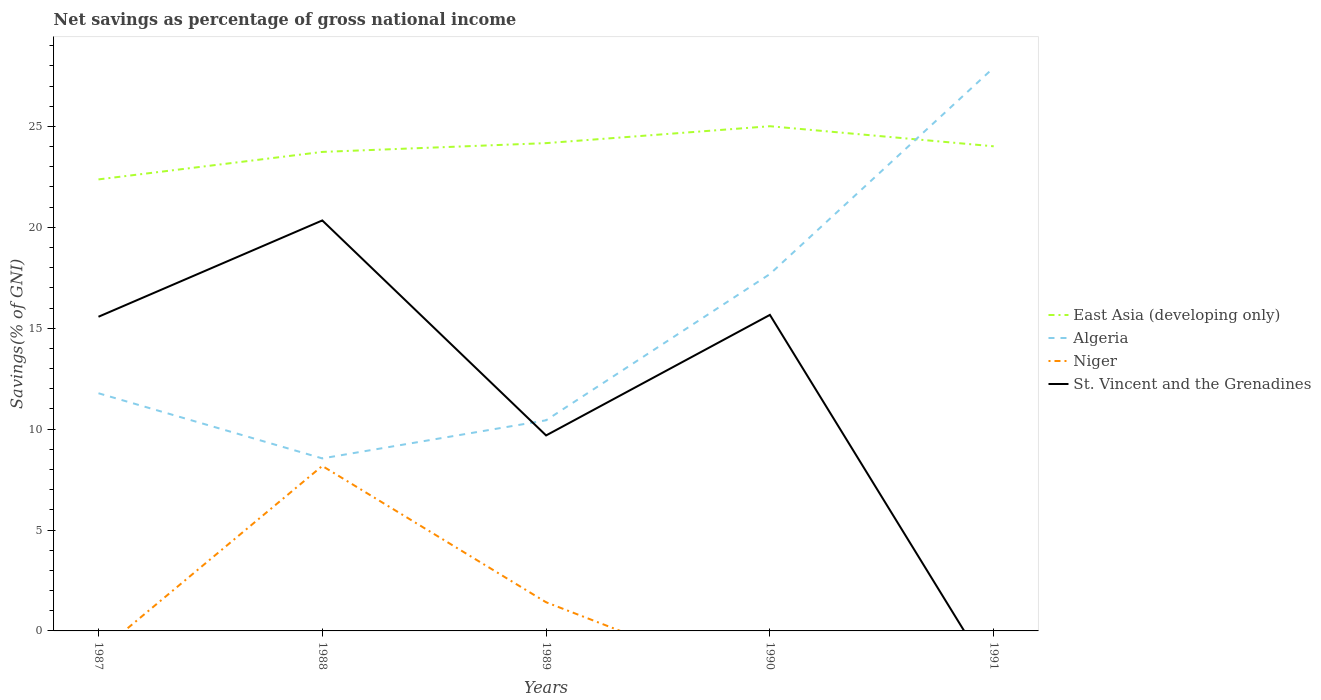How many different coloured lines are there?
Offer a very short reply. 4. Does the line corresponding to St. Vincent and the Grenadines intersect with the line corresponding to Niger?
Keep it short and to the point. Yes. What is the total total savings in Algeria in the graph?
Provide a short and direct response. -5.91. What is the difference between the highest and the second highest total savings in St. Vincent and the Grenadines?
Make the answer very short. 20.34. What is the difference between the highest and the lowest total savings in Algeria?
Offer a very short reply. 2. Is the total savings in Niger strictly greater than the total savings in East Asia (developing only) over the years?
Provide a succinct answer. Yes. Does the graph contain any zero values?
Your response must be concise. Yes. Does the graph contain grids?
Make the answer very short. No. Where does the legend appear in the graph?
Provide a short and direct response. Center right. How many legend labels are there?
Give a very brief answer. 4. How are the legend labels stacked?
Your answer should be very brief. Vertical. What is the title of the graph?
Ensure brevity in your answer.  Net savings as percentage of gross national income. Does "South Sudan" appear as one of the legend labels in the graph?
Provide a short and direct response. No. What is the label or title of the Y-axis?
Keep it short and to the point. Savings(% of GNI). What is the Savings(% of GNI) of East Asia (developing only) in 1987?
Provide a succinct answer. 22.38. What is the Savings(% of GNI) in Algeria in 1987?
Provide a succinct answer. 11.78. What is the Savings(% of GNI) of St. Vincent and the Grenadines in 1987?
Your response must be concise. 15.57. What is the Savings(% of GNI) of East Asia (developing only) in 1988?
Provide a succinct answer. 23.74. What is the Savings(% of GNI) of Algeria in 1988?
Your response must be concise. 8.55. What is the Savings(% of GNI) of Niger in 1988?
Keep it short and to the point. 8.18. What is the Savings(% of GNI) of St. Vincent and the Grenadines in 1988?
Provide a short and direct response. 20.34. What is the Savings(% of GNI) of East Asia (developing only) in 1989?
Provide a succinct answer. 24.17. What is the Savings(% of GNI) in Algeria in 1989?
Offer a very short reply. 10.44. What is the Savings(% of GNI) of Niger in 1989?
Provide a succinct answer. 1.42. What is the Savings(% of GNI) of St. Vincent and the Grenadines in 1989?
Your response must be concise. 9.69. What is the Savings(% of GNI) in East Asia (developing only) in 1990?
Provide a succinct answer. 25.01. What is the Savings(% of GNI) in Algeria in 1990?
Offer a terse response. 17.69. What is the Savings(% of GNI) in Niger in 1990?
Keep it short and to the point. 0. What is the Savings(% of GNI) in St. Vincent and the Grenadines in 1990?
Your answer should be compact. 15.66. What is the Savings(% of GNI) in East Asia (developing only) in 1991?
Offer a terse response. 24.02. What is the Savings(% of GNI) in Algeria in 1991?
Provide a succinct answer. 27.91. What is the Savings(% of GNI) in St. Vincent and the Grenadines in 1991?
Your answer should be very brief. 0. Across all years, what is the maximum Savings(% of GNI) in East Asia (developing only)?
Provide a short and direct response. 25.01. Across all years, what is the maximum Savings(% of GNI) of Algeria?
Your response must be concise. 27.91. Across all years, what is the maximum Savings(% of GNI) in Niger?
Offer a terse response. 8.18. Across all years, what is the maximum Savings(% of GNI) of St. Vincent and the Grenadines?
Offer a terse response. 20.34. Across all years, what is the minimum Savings(% of GNI) of East Asia (developing only)?
Offer a terse response. 22.38. Across all years, what is the minimum Savings(% of GNI) of Algeria?
Your response must be concise. 8.55. Across all years, what is the minimum Savings(% of GNI) in Niger?
Keep it short and to the point. 0. What is the total Savings(% of GNI) of East Asia (developing only) in the graph?
Your answer should be compact. 119.31. What is the total Savings(% of GNI) of Algeria in the graph?
Provide a short and direct response. 76.37. What is the total Savings(% of GNI) of Niger in the graph?
Make the answer very short. 9.6. What is the total Savings(% of GNI) of St. Vincent and the Grenadines in the graph?
Provide a short and direct response. 61.26. What is the difference between the Savings(% of GNI) of East Asia (developing only) in 1987 and that in 1988?
Offer a terse response. -1.36. What is the difference between the Savings(% of GNI) in Algeria in 1987 and that in 1988?
Keep it short and to the point. 3.23. What is the difference between the Savings(% of GNI) in St. Vincent and the Grenadines in 1987 and that in 1988?
Ensure brevity in your answer.  -4.77. What is the difference between the Savings(% of GNI) in East Asia (developing only) in 1987 and that in 1989?
Provide a succinct answer. -1.8. What is the difference between the Savings(% of GNI) in Algeria in 1987 and that in 1989?
Make the answer very short. 1.34. What is the difference between the Savings(% of GNI) of St. Vincent and the Grenadines in 1987 and that in 1989?
Offer a terse response. 5.88. What is the difference between the Savings(% of GNI) of East Asia (developing only) in 1987 and that in 1990?
Your answer should be compact. -2.63. What is the difference between the Savings(% of GNI) of Algeria in 1987 and that in 1990?
Your response must be concise. -5.91. What is the difference between the Savings(% of GNI) in St. Vincent and the Grenadines in 1987 and that in 1990?
Your answer should be very brief. -0.09. What is the difference between the Savings(% of GNI) in East Asia (developing only) in 1987 and that in 1991?
Your answer should be very brief. -1.64. What is the difference between the Savings(% of GNI) in Algeria in 1987 and that in 1991?
Your response must be concise. -16.14. What is the difference between the Savings(% of GNI) in East Asia (developing only) in 1988 and that in 1989?
Ensure brevity in your answer.  -0.44. What is the difference between the Savings(% of GNI) of Algeria in 1988 and that in 1989?
Give a very brief answer. -1.89. What is the difference between the Savings(% of GNI) of Niger in 1988 and that in 1989?
Keep it short and to the point. 6.76. What is the difference between the Savings(% of GNI) of St. Vincent and the Grenadines in 1988 and that in 1989?
Your answer should be very brief. 10.65. What is the difference between the Savings(% of GNI) of East Asia (developing only) in 1988 and that in 1990?
Keep it short and to the point. -1.27. What is the difference between the Savings(% of GNI) of Algeria in 1988 and that in 1990?
Your answer should be compact. -9.14. What is the difference between the Savings(% of GNI) in St. Vincent and the Grenadines in 1988 and that in 1990?
Provide a succinct answer. 4.68. What is the difference between the Savings(% of GNI) of East Asia (developing only) in 1988 and that in 1991?
Your response must be concise. -0.28. What is the difference between the Savings(% of GNI) in Algeria in 1988 and that in 1991?
Your answer should be very brief. -19.36. What is the difference between the Savings(% of GNI) in East Asia (developing only) in 1989 and that in 1990?
Your answer should be very brief. -0.84. What is the difference between the Savings(% of GNI) in Algeria in 1989 and that in 1990?
Your answer should be very brief. -7.25. What is the difference between the Savings(% of GNI) of St. Vincent and the Grenadines in 1989 and that in 1990?
Make the answer very short. -5.97. What is the difference between the Savings(% of GNI) of East Asia (developing only) in 1989 and that in 1991?
Make the answer very short. 0.16. What is the difference between the Savings(% of GNI) of Algeria in 1989 and that in 1991?
Give a very brief answer. -17.48. What is the difference between the Savings(% of GNI) in East Asia (developing only) in 1990 and that in 1991?
Provide a succinct answer. 1. What is the difference between the Savings(% of GNI) in Algeria in 1990 and that in 1991?
Provide a succinct answer. -10.23. What is the difference between the Savings(% of GNI) of East Asia (developing only) in 1987 and the Savings(% of GNI) of Algeria in 1988?
Offer a terse response. 13.83. What is the difference between the Savings(% of GNI) in East Asia (developing only) in 1987 and the Savings(% of GNI) in Niger in 1988?
Provide a short and direct response. 14.2. What is the difference between the Savings(% of GNI) in East Asia (developing only) in 1987 and the Savings(% of GNI) in St. Vincent and the Grenadines in 1988?
Offer a terse response. 2.03. What is the difference between the Savings(% of GNI) of Algeria in 1987 and the Savings(% of GNI) of Niger in 1988?
Make the answer very short. 3.6. What is the difference between the Savings(% of GNI) of Algeria in 1987 and the Savings(% of GNI) of St. Vincent and the Grenadines in 1988?
Provide a short and direct response. -8.56. What is the difference between the Savings(% of GNI) of East Asia (developing only) in 1987 and the Savings(% of GNI) of Algeria in 1989?
Keep it short and to the point. 11.94. What is the difference between the Savings(% of GNI) of East Asia (developing only) in 1987 and the Savings(% of GNI) of Niger in 1989?
Your answer should be very brief. 20.96. What is the difference between the Savings(% of GNI) in East Asia (developing only) in 1987 and the Savings(% of GNI) in St. Vincent and the Grenadines in 1989?
Keep it short and to the point. 12.69. What is the difference between the Savings(% of GNI) of Algeria in 1987 and the Savings(% of GNI) of Niger in 1989?
Offer a terse response. 10.36. What is the difference between the Savings(% of GNI) of Algeria in 1987 and the Savings(% of GNI) of St. Vincent and the Grenadines in 1989?
Your response must be concise. 2.09. What is the difference between the Savings(% of GNI) of East Asia (developing only) in 1987 and the Savings(% of GNI) of Algeria in 1990?
Your answer should be very brief. 4.69. What is the difference between the Savings(% of GNI) of East Asia (developing only) in 1987 and the Savings(% of GNI) of St. Vincent and the Grenadines in 1990?
Offer a very short reply. 6.71. What is the difference between the Savings(% of GNI) of Algeria in 1987 and the Savings(% of GNI) of St. Vincent and the Grenadines in 1990?
Ensure brevity in your answer.  -3.88. What is the difference between the Savings(% of GNI) of East Asia (developing only) in 1987 and the Savings(% of GNI) of Algeria in 1991?
Your answer should be very brief. -5.54. What is the difference between the Savings(% of GNI) in East Asia (developing only) in 1988 and the Savings(% of GNI) in Algeria in 1989?
Your answer should be compact. 13.3. What is the difference between the Savings(% of GNI) of East Asia (developing only) in 1988 and the Savings(% of GNI) of Niger in 1989?
Provide a succinct answer. 22.32. What is the difference between the Savings(% of GNI) of East Asia (developing only) in 1988 and the Savings(% of GNI) of St. Vincent and the Grenadines in 1989?
Provide a short and direct response. 14.05. What is the difference between the Savings(% of GNI) in Algeria in 1988 and the Savings(% of GNI) in Niger in 1989?
Your answer should be compact. 7.13. What is the difference between the Savings(% of GNI) of Algeria in 1988 and the Savings(% of GNI) of St. Vincent and the Grenadines in 1989?
Offer a terse response. -1.14. What is the difference between the Savings(% of GNI) of Niger in 1988 and the Savings(% of GNI) of St. Vincent and the Grenadines in 1989?
Provide a short and direct response. -1.51. What is the difference between the Savings(% of GNI) of East Asia (developing only) in 1988 and the Savings(% of GNI) of Algeria in 1990?
Offer a very short reply. 6.05. What is the difference between the Savings(% of GNI) in East Asia (developing only) in 1988 and the Savings(% of GNI) in St. Vincent and the Grenadines in 1990?
Your answer should be very brief. 8.08. What is the difference between the Savings(% of GNI) of Algeria in 1988 and the Savings(% of GNI) of St. Vincent and the Grenadines in 1990?
Your answer should be compact. -7.11. What is the difference between the Savings(% of GNI) of Niger in 1988 and the Savings(% of GNI) of St. Vincent and the Grenadines in 1990?
Ensure brevity in your answer.  -7.49. What is the difference between the Savings(% of GNI) of East Asia (developing only) in 1988 and the Savings(% of GNI) of Algeria in 1991?
Make the answer very short. -4.18. What is the difference between the Savings(% of GNI) of East Asia (developing only) in 1989 and the Savings(% of GNI) of Algeria in 1990?
Provide a short and direct response. 6.49. What is the difference between the Savings(% of GNI) in East Asia (developing only) in 1989 and the Savings(% of GNI) in St. Vincent and the Grenadines in 1990?
Offer a very short reply. 8.51. What is the difference between the Savings(% of GNI) of Algeria in 1989 and the Savings(% of GNI) of St. Vincent and the Grenadines in 1990?
Keep it short and to the point. -5.22. What is the difference between the Savings(% of GNI) of Niger in 1989 and the Savings(% of GNI) of St. Vincent and the Grenadines in 1990?
Offer a very short reply. -14.24. What is the difference between the Savings(% of GNI) of East Asia (developing only) in 1989 and the Savings(% of GNI) of Algeria in 1991?
Offer a terse response. -3.74. What is the difference between the Savings(% of GNI) of East Asia (developing only) in 1990 and the Savings(% of GNI) of Algeria in 1991?
Ensure brevity in your answer.  -2.9. What is the average Savings(% of GNI) of East Asia (developing only) per year?
Your response must be concise. 23.86. What is the average Savings(% of GNI) in Algeria per year?
Offer a terse response. 15.27. What is the average Savings(% of GNI) of Niger per year?
Your response must be concise. 1.92. What is the average Savings(% of GNI) of St. Vincent and the Grenadines per year?
Ensure brevity in your answer.  12.25. In the year 1987, what is the difference between the Savings(% of GNI) in East Asia (developing only) and Savings(% of GNI) in Algeria?
Your answer should be compact. 10.6. In the year 1987, what is the difference between the Savings(% of GNI) in East Asia (developing only) and Savings(% of GNI) in St. Vincent and the Grenadines?
Your response must be concise. 6.81. In the year 1987, what is the difference between the Savings(% of GNI) in Algeria and Savings(% of GNI) in St. Vincent and the Grenadines?
Offer a terse response. -3.79. In the year 1988, what is the difference between the Savings(% of GNI) of East Asia (developing only) and Savings(% of GNI) of Algeria?
Provide a succinct answer. 15.19. In the year 1988, what is the difference between the Savings(% of GNI) of East Asia (developing only) and Savings(% of GNI) of Niger?
Offer a terse response. 15.56. In the year 1988, what is the difference between the Savings(% of GNI) in East Asia (developing only) and Savings(% of GNI) in St. Vincent and the Grenadines?
Your answer should be compact. 3.4. In the year 1988, what is the difference between the Savings(% of GNI) of Algeria and Savings(% of GNI) of Niger?
Provide a succinct answer. 0.37. In the year 1988, what is the difference between the Savings(% of GNI) in Algeria and Savings(% of GNI) in St. Vincent and the Grenadines?
Your response must be concise. -11.79. In the year 1988, what is the difference between the Savings(% of GNI) in Niger and Savings(% of GNI) in St. Vincent and the Grenadines?
Keep it short and to the point. -12.17. In the year 1989, what is the difference between the Savings(% of GNI) of East Asia (developing only) and Savings(% of GNI) of Algeria?
Your answer should be very brief. 13.73. In the year 1989, what is the difference between the Savings(% of GNI) of East Asia (developing only) and Savings(% of GNI) of Niger?
Provide a succinct answer. 22.75. In the year 1989, what is the difference between the Savings(% of GNI) of East Asia (developing only) and Savings(% of GNI) of St. Vincent and the Grenadines?
Offer a very short reply. 14.49. In the year 1989, what is the difference between the Savings(% of GNI) in Algeria and Savings(% of GNI) in Niger?
Give a very brief answer. 9.02. In the year 1989, what is the difference between the Savings(% of GNI) in Algeria and Savings(% of GNI) in St. Vincent and the Grenadines?
Keep it short and to the point. 0.75. In the year 1989, what is the difference between the Savings(% of GNI) of Niger and Savings(% of GNI) of St. Vincent and the Grenadines?
Your answer should be very brief. -8.27. In the year 1990, what is the difference between the Savings(% of GNI) in East Asia (developing only) and Savings(% of GNI) in Algeria?
Your answer should be compact. 7.32. In the year 1990, what is the difference between the Savings(% of GNI) in East Asia (developing only) and Savings(% of GNI) in St. Vincent and the Grenadines?
Your answer should be very brief. 9.35. In the year 1990, what is the difference between the Savings(% of GNI) of Algeria and Savings(% of GNI) of St. Vincent and the Grenadines?
Offer a very short reply. 2.02. In the year 1991, what is the difference between the Savings(% of GNI) in East Asia (developing only) and Savings(% of GNI) in Algeria?
Ensure brevity in your answer.  -3.9. What is the ratio of the Savings(% of GNI) in East Asia (developing only) in 1987 to that in 1988?
Your answer should be very brief. 0.94. What is the ratio of the Savings(% of GNI) in Algeria in 1987 to that in 1988?
Give a very brief answer. 1.38. What is the ratio of the Savings(% of GNI) of St. Vincent and the Grenadines in 1987 to that in 1988?
Offer a very short reply. 0.77. What is the ratio of the Savings(% of GNI) in East Asia (developing only) in 1987 to that in 1989?
Your response must be concise. 0.93. What is the ratio of the Savings(% of GNI) in Algeria in 1987 to that in 1989?
Your response must be concise. 1.13. What is the ratio of the Savings(% of GNI) of St. Vincent and the Grenadines in 1987 to that in 1989?
Ensure brevity in your answer.  1.61. What is the ratio of the Savings(% of GNI) of East Asia (developing only) in 1987 to that in 1990?
Keep it short and to the point. 0.89. What is the ratio of the Savings(% of GNI) of Algeria in 1987 to that in 1990?
Provide a short and direct response. 0.67. What is the ratio of the Savings(% of GNI) of East Asia (developing only) in 1987 to that in 1991?
Offer a very short reply. 0.93. What is the ratio of the Savings(% of GNI) in Algeria in 1987 to that in 1991?
Make the answer very short. 0.42. What is the ratio of the Savings(% of GNI) of Algeria in 1988 to that in 1989?
Your answer should be compact. 0.82. What is the ratio of the Savings(% of GNI) in Niger in 1988 to that in 1989?
Keep it short and to the point. 5.76. What is the ratio of the Savings(% of GNI) of St. Vincent and the Grenadines in 1988 to that in 1989?
Provide a short and direct response. 2.1. What is the ratio of the Savings(% of GNI) in East Asia (developing only) in 1988 to that in 1990?
Offer a terse response. 0.95. What is the ratio of the Savings(% of GNI) of Algeria in 1988 to that in 1990?
Keep it short and to the point. 0.48. What is the ratio of the Savings(% of GNI) in St. Vincent and the Grenadines in 1988 to that in 1990?
Make the answer very short. 1.3. What is the ratio of the Savings(% of GNI) in East Asia (developing only) in 1988 to that in 1991?
Keep it short and to the point. 0.99. What is the ratio of the Savings(% of GNI) of Algeria in 1988 to that in 1991?
Provide a succinct answer. 0.31. What is the ratio of the Savings(% of GNI) of East Asia (developing only) in 1989 to that in 1990?
Make the answer very short. 0.97. What is the ratio of the Savings(% of GNI) of Algeria in 1989 to that in 1990?
Your response must be concise. 0.59. What is the ratio of the Savings(% of GNI) of St. Vincent and the Grenadines in 1989 to that in 1990?
Make the answer very short. 0.62. What is the ratio of the Savings(% of GNI) of East Asia (developing only) in 1989 to that in 1991?
Provide a short and direct response. 1.01. What is the ratio of the Savings(% of GNI) in Algeria in 1989 to that in 1991?
Provide a short and direct response. 0.37. What is the ratio of the Savings(% of GNI) of East Asia (developing only) in 1990 to that in 1991?
Offer a terse response. 1.04. What is the ratio of the Savings(% of GNI) in Algeria in 1990 to that in 1991?
Keep it short and to the point. 0.63. What is the difference between the highest and the second highest Savings(% of GNI) in East Asia (developing only)?
Provide a short and direct response. 0.84. What is the difference between the highest and the second highest Savings(% of GNI) of Algeria?
Offer a terse response. 10.23. What is the difference between the highest and the second highest Savings(% of GNI) of St. Vincent and the Grenadines?
Provide a succinct answer. 4.68. What is the difference between the highest and the lowest Savings(% of GNI) of East Asia (developing only)?
Ensure brevity in your answer.  2.63. What is the difference between the highest and the lowest Savings(% of GNI) of Algeria?
Your answer should be compact. 19.36. What is the difference between the highest and the lowest Savings(% of GNI) of Niger?
Provide a short and direct response. 8.18. What is the difference between the highest and the lowest Savings(% of GNI) in St. Vincent and the Grenadines?
Your answer should be compact. 20.34. 